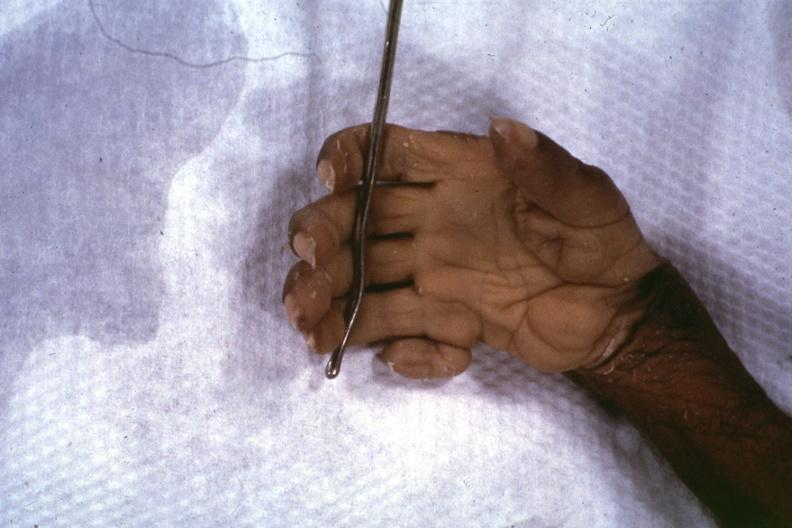s very good example present?
Answer the question using a single word or phrase. Yes 